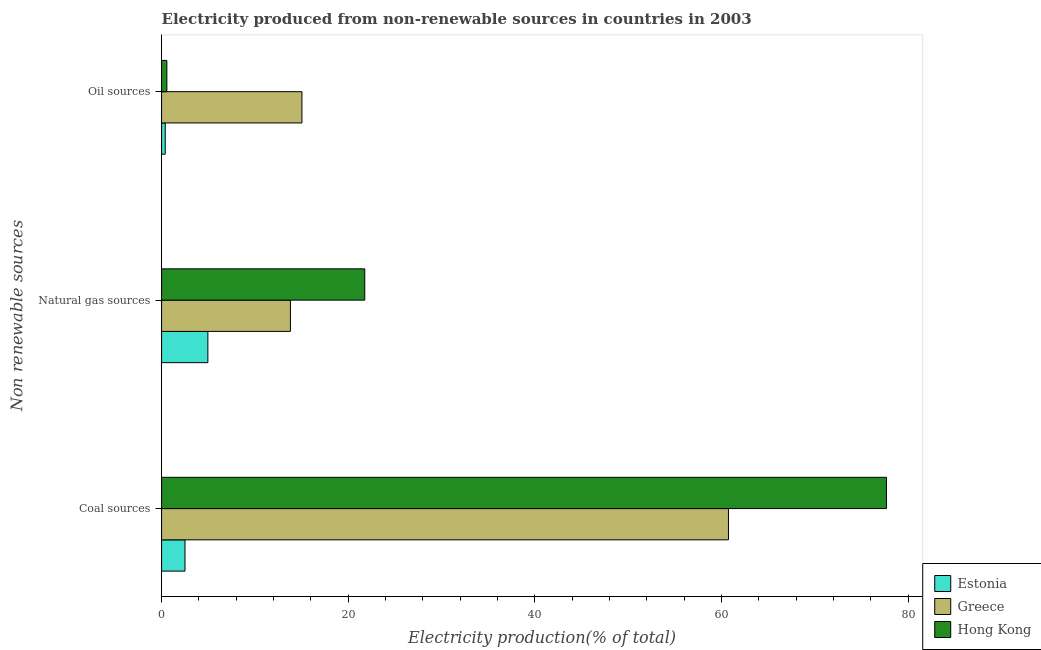How many different coloured bars are there?
Your response must be concise. 3. How many groups of bars are there?
Your answer should be very brief. 3. Are the number of bars per tick equal to the number of legend labels?
Keep it short and to the point. Yes. How many bars are there on the 1st tick from the top?
Provide a succinct answer. 3. How many bars are there on the 2nd tick from the bottom?
Provide a short and direct response. 3. What is the label of the 2nd group of bars from the top?
Your answer should be compact. Natural gas sources. What is the percentage of electricity produced by coal in Greece?
Your response must be concise. 60.74. Across all countries, what is the maximum percentage of electricity produced by oil sources?
Your answer should be compact. 15.04. Across all countries, what is the minimum percentage of electricity produced by oil sources?
Keep it short and to the point. 0.39. In which country was the percentage of electricity produced by coal maximum?
Provide a short and direct response. Hong Kong. In which country was the percentage of electricity produced by oil sources minimum?
Provide a succinct answer. Estonia. What is the total percentage of electricity produced by natural gas in the graph?
Your answer should be very brief. 40.54. What is the difference between the percentage of electricity produced by coal in Hong Kong and that in Greece?
Your answer should be compact. 16.93. What is the difference between the percentage of electricity produced by coal in Estonia and the percentage of electricity produced by natural gas in Greece?
Provide a succinct answer. -11.3. What is the average percentage of electricity produced by coal per country?
Give a very brief answer. 46.97. What is the difference between the percentage of electricity produced by natural gas and percentage of electricity produced by coal in Hong Kong?
Your answer should be compact. -55.9. In how many countries, is the percentage of electricity produced by oil sources greater than 32 %?
Make the answer very short. 0. What is the ratio of the percentage of electricity produced by coal in Greece to that in Estonia?
Your response must be concise. 24.2. Is the percentage of electricity produced by oil sources in Hong Kong less than that in Greece?
Ensure brevity in your answer.  Yes. Is the difference between the percentage of electricity produced by natural gas in Hong Kong and Greece greater than the difference between the percentage of electricity produced by coal in Hong Kong and Greece?
Give a very brief answer. No. What is the difference between the highest and the second highest percentage of electricity produced by oil sources?
Your response must be concise. 14.47. What is the difference between the highest and the lowest percentage of electricity produced by natural gas?
Offer a terse response. 16.81. Is the sum of the percentage of electricity produced by natural gas in Estonia and Hong Kong greater than the maximum percentage of electricity produced by oil sources across all countries?
Your answer should be compact. Yes. What does the 3rd bar from the top in Coal sources represents?
Offer a very short reply. Estonia. What does the 2nd bar from the bottom in Oil sources represents?
Offer a terse response. Greece. Are all the bars in the graph horizontal?
Give a very brief answer. Yes. What is the difference between two consecutive major ticks on the X-axis?
Make the answer very short. 20. Where does the legend appear in the graph?
Offer a terse response. Bottom right. How many legend labels are there?
Your answer should be compact. 3. What is the title of the graph?
Give a very brief answer. Electricity produced from non-renewable sources in countries in 2003. Does "South Africa" appear as one of the legend labels in the graph?
Offer a terse response. No. What is the label or title of the Y-axis?
Your answer should be compact. Non renewable sources. What is the Electricity production(% of total) of Estonia in Coal sources?
Ensure brevity in your answer.  2.51. What is the Electricity production(% of total) in Greece in Coal sources?
Offer a terse response. 60.74. What is the Electricity production(% of total) in Hong Kong in Coal sources?
Keep it short and to the point. 77.66. What is the Electricity production(% of total) in Estonia in Natural gas sources?
Give a very brief answer. 4.96. What is the Electricity production(% of total) of Greece in Natural gas sources?
Ensure brevity in your answer.  13.81. What is the Electricity production(% of total) in Hong Kong in Natural gas sources?
Make the answer very short. 21.77. What is the Electricity production(% of total) in Estonia in Oil sources?
Your answer should be compact. 0.39. What is the Electricity production(% of total) in Greece in Oil sources?
Provide a succinct answer. 15.04. What is the Electricity production(% of total) in Hong Kong in Oil sources?
Give a very brief answer. 0.57. Across all Non renewable sources, what is the maximum Electricity production(% of total) of Estonia?
Offer a terse response. 4.96. Across all Non renewable sources, what is the maximum Electricity production(% of total) of Greece?
Keep it short and to the point. 60.74. Across all Non renewable sources, what is the maximum Electricity production(% of total) of Hong Kong?
Your answer should be compact. 77.66. Across all Non renewable sources, what is the minimum Electricity production(% of total) in Estonia?
Your answer should be compact. 0.39. Across all Non renewable sources, what is the minimum Electricity production(% of total) in Greece?
Your answer should be compact. 13.81. Across all Non renewable sources, what is the minimum Electricity production(% of total) in Hong Kong?
Keep it short and to the point. 0.57. What is the total Electricity production(% of total) in Estonia in the graph?
Provide a short and direct response. 7.86. What is the total Electricity production(% of total) in Greece in the graph?
Provide a short and direct response. 89.58. What is the difference between the Electricity production(% of total) of Estonia in Coal sources and that in Natural gas sources?
Provide a succinct answer. -2.45. What is the difference between the Electricity production(% of total) in Greece in Coal sources and that in Natural gas sources?
Provide a succinct answer. 46.93. What is the difference between the Electricity production(% of total) in Hong Kong in Coal sources and that in Natural gas sources?
Provide a short and direct response. 55.9. What is the difference between the Electricity production(% of total) in Estonia in Coal sources and that in Oil sources?
Provide a short and direct response. 2.12. What is the difference between the Electricity production(% of total) in Greece in Coal sources and that in Oil sources?
Your answer should be very brief. 45.7. What is the difference between the Electricity production(% of total) in Hong Kong in Coal sources and that in Oil sources?
Ensure brevity in your answer.  77.1. What is the difference between the Electricity production(% of total) in Estonia in Natural gas sources and that in Oil sources?
Your response must be concise. 4.57. What is the difference between the Electricity production(% of total) of Greece in Natural gas sources and that in Oil sources?
Provide a succinct answer. -1.23. What is the difference between the Electricity production(% of total) in Hong Kong in Natural gas sources and that in Oil sources?
Make the answer very short. 21.2. What is the difference between the Electricity production(% of total) of Estonia in Coal sources and the Electricity production(% of total) of Greece in Natural gas sources?
Your answer should be compact. -11.3. What is the difference between the Electricity production(% of total) of Estonia in Coal sources and the Electricity production(% of total) of Hong Kong in Natural gas sources?
Provide a succinct answer. -19.26. What is the difference between the Electricity production(% of total) in Greece in Coal sources and the Electricity production(% of total) in Hong Kong in Natural gas sources?
Provide a succinct answer. 38.97. What is the difference between the Electricity production(% of total) in Estonia in Coal sources and the Electricity production(% of total) in Greece in Oil sources?
Make the answer very short. -12.53. What is the difference between the Electricity production(% of total) of Estonia in Coal sources and the Electricity production(% of total) of Hong Kong in Oil sources?
Keep it short and to the point. 1.94. What is the difference between the Electricity production(% of total) in Greece in Coal sources and the Electricity production(% of total) in Hong Kong in Oil sources?
Provide a succinct answer. 60.17. What is the difference between the Electricity production(% of total) in Estonia in Natural gas sources and the Electricity production(% of total) in Greece in Oil sources?
Your response must be concise. -10.08. What is the difference between the Electricity production(% of total) in Estonia in Natural gas sources and the Electricity production(% of total) in Hong Kong in Oil sources?
Offer a very short reply. 4.4. What is the difference between the Electricity production(% of total) in Greece in Natural gas sources and the Electricity production(% of total) in Hong Kong in Oil sources?
Your answer should be very brief. 13.24. What is the average Electricity production(% of total) of Estonia per Non renewable sources?
Your response must be concise. 2.62. What is the average Electricity production(% of total) of Greece per Non renewable sources?
Keep it short and to the point. 29.86. What is the average Electricity production(% of total) of Hong Kong per Non renewable sources?
Your answer should be compact. 33.33. What is the difference between the Electricity production(% of total) of Estonia and Electricity production(% of total) of Greece in Coal sources?
Your answer should be compact. -58.23. What is the difference between the Electricity production(% of total) in Estonia and Electricity production(% of total) in Hong Kong in Coal sources?
Make the answer very short. -75.15. What is the difference between the Electricity production(% of total) of Greece and Electricity production(% of total) of Hong Kong in Coal sources?
Your response must be concise. -16.93. What is the difference between the Electricity production(% of total) in Estonia and Electricity production(% of total) in Greece in Natural gas sources?
Keep it short and to the point. -8.85. What is the difference between the Electricity production(% of total) in Estonia and Electricity production(% of total) in Hong Kong in Natural gas sources?
Offer a terse response. -16.81. What is the difference between the Electricity production(% of total) of Greece and Electricity production(% of total) of Hong Kong in Natural gas sources?
Offer a very short reply. -7.96. What is the difference between the Electricity production(% of total) of Estonia and Electricity production(% of total) of Greece in Oil sources?
Offer a very short reply. -14.64. What is the difference between the Electricity production(% of total) of Estonia and Electricity production(% of total) of Hong Kong in Oil sources?
Your answer should be compact. -0.17. What is the difference between the Electricity production(% of total) in Greece and Electricity production(% of total) in Hong Kong in Oil sources?
Provide a short and direct response. 14.47. What is the ratio of the Electricity production(% of total) of Estonia in Coal sources to that in Natural gas sources?
Offer a terse response. 0.51. What is the ratio of the Electricity production(% of total) in Greece in Coal sources to that in Natural gas sources?
Your response must be concise. 4.4. What is the ratio of the Electricity production(% of total) of Hong Kong in Coal sources to that in Natural gas sources?
Offer a very short reply. 3.57. What is the ratio of the Electricity production(% of total) of Estonia in Coal sources to that in Oil sources?
Make the answer very short. 6.38. What is the ratio of the Electricity production(% of total) in Greece in Coal sources to that in Oil sources?
Make the answer very short. 4.04. What is the ratio of the Electricity production(% of total) of Hong Kong in Coal sources to that in Oil sources?
Your answer should be compact. 137.2. What is the ratio of the Electricity production(% of total) in Greece in Natural gas sources to that in Oil sources?
Provide a succinct answer. 0.92. What is the ratio of the Electricity production(% of total) of Hong Kong in Natural gas sources to that in Oil sources?
Offer a very short reply. 38.46. What is the difference between the highest and the second highest Electricity production(% of total) in Estonia?
Your answer should be compact. 2.45. What is the difference between the highest and the second highest Electricity production(% of total) in Greece?
Give a very brief answer. 45.7. What is the difference between the highest and the second highest Electricity production(% of total) in Hong Kong?
Make the answer very short. 55.9. What is the difference between the highest and the lowest Electricity production(% of total) of Estonia?
Offer a very short reply. 4.57. What is the difference between the highest and the lowest Electricity production(% of total) in Greece?
Offer a very short reply. 46.93. What is the difference between the highest and the lowest Electricity production(% of total) of Hong Kong?
Your answer should be compact. 77.1. 